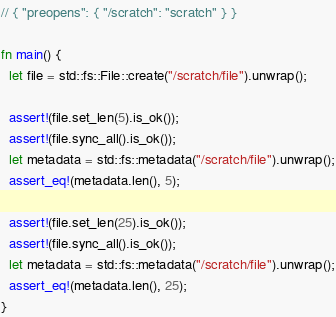Convert code to text. <code><loc_0><loc_0><loc_500><loc_500><_Rust_>// { "preopens": { "/scratch": "scratch" } }

fn main() {
  let file = std::fs::File::create("/scratch/file").unwrap();

  assert!(file.set_len(5).is_ok());
  assert!(file.sync_all().is_ok());
  let metadata = std::fs::metadata("/scratch/file").unwrap();
  assert_eq!(metadata.len(), 5);

  assert!(file.set_len(25).is_ok());
  assert!(file.sync_all().is_ok());
  let metadata = std::fs::metadata("/scratch/file").unwrap();
  assert_eq!(metadata.len(), 25);
}
</code> 